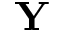<formula> <loc_0><loc_0><loc_500><loc_500>Y</formula> 